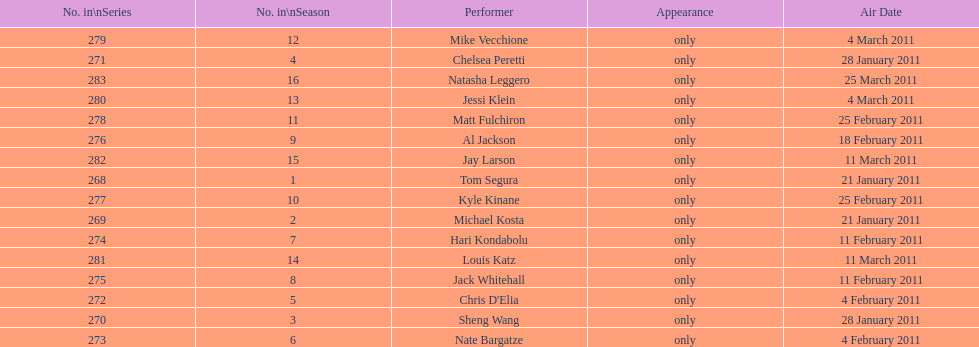How many different performers appeared during this season? 16. 